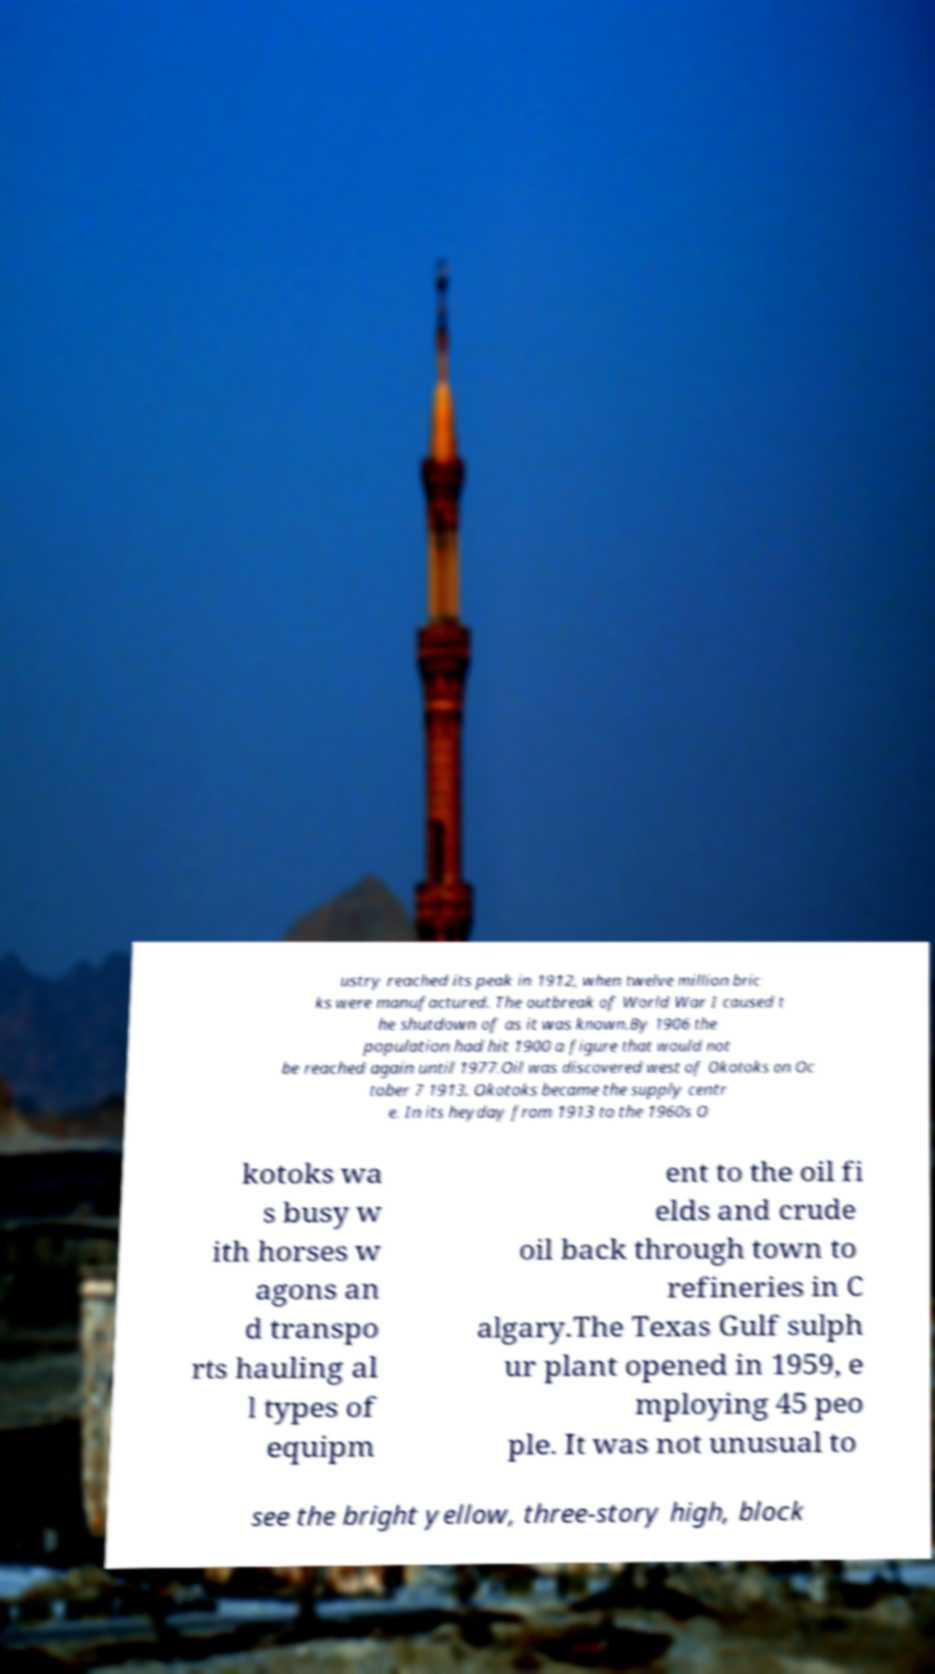What messages or text are displayed in this image? I need them in a readable, typed format. ustry reached its peak in 1912, when twelve million bric ks were manufactured. The outbreak of World War I caused t he shutdown of as it was known.By 1906 the population had hit 1900 a figure that would not be reached again until 1977.Oil was discovered west of Okotoks on Oc tober 7 1913. Okotoks became the supply centr e. In its heyday from 1913 to the 1960s O kotoks wa s busy w ith horses w agons an d transpo rts hauling al l types of equipm ent to the oil fi elds and crude oil back through town to refineries in C algary.The Texas Gulf sulph ur plant opened in 1959, e mploying 45 peo ple. It was not unusual to see the bright yellow, three-story high, block 